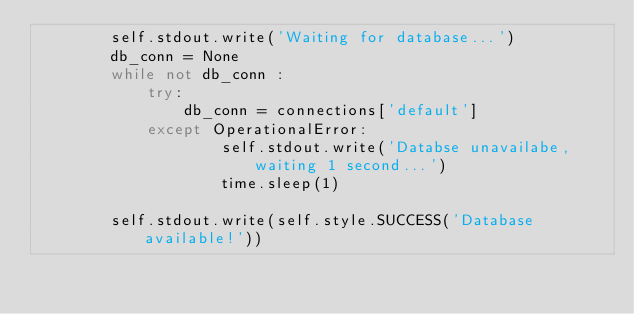<code> <loc_0><loc_0><loc_500><loc_500><_Python_>        self.stdout.write('Waiting for database...')
        db_conn = None
        while not db_conn :
            try:
                db_conn = connections['default']
            except OperationalError:
                    self.stdout.write('Databse unavailabe, waiting 1 second...')
                    time.sleep(1)

        self.stdout.write(self.style.SUCCESS('Database available!'))                </code> 